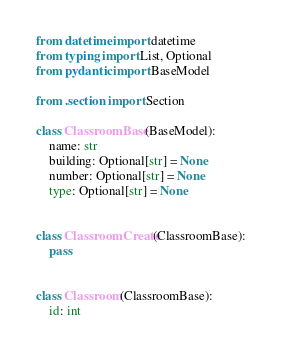<code> <loc_0><loc_0><loc_500><loc_500><_Python_>from datetime import datetime
from typing import List, Optional
from pydantic import BaseModel

from .section import Section

class ClassroomBase(BaseModel):
    name: str
    building: Optional[str] = None
    number: Optional[str] = None
    type: Optional[str] = None


class ClassroomCreate(ClassroomBase):
    pass


class Classroom(ClassroomBase):
    id: int</code> 